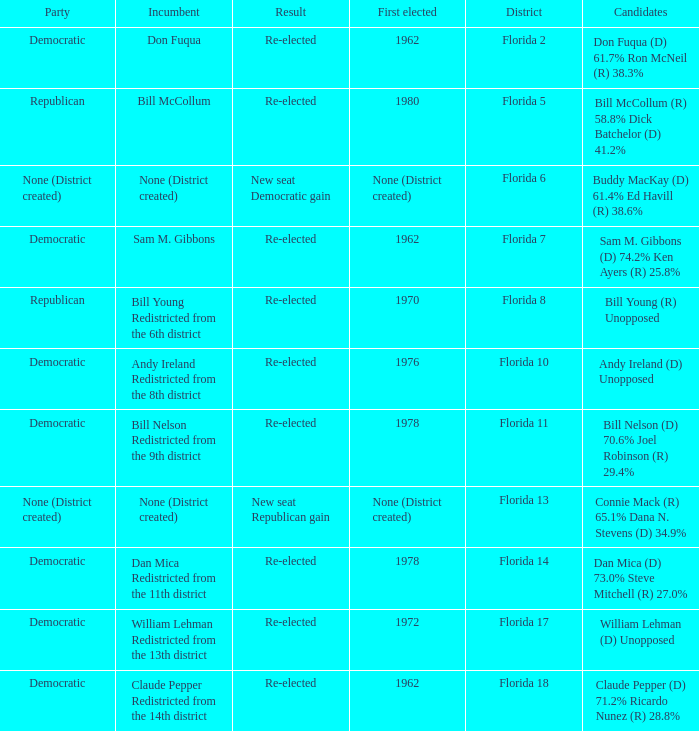What's the first elected with district being florida 7 1962.0. Would you mind parsing the complete table? {'header': ['Party', 'Incumbent', 'Result', 'First elected', 'District', 'Candidates'], 'rows': [['Democratic', 'Don Fuqua', 'Re-elected', '1962', 'Florida 2', 'Don Fuqua (D) 61.7% Ron McNeil (R) 38.3%'], ['Republican', 'Bill McCollum', 'Re-elected', '1980', 'Florida 5', 'Bill McCollum (R) 58.8% Dick Batchelor (D) 41.2%'], ['None (District created)', 'None (District created)', 'New seat Democratic gain', 'None (District created)', 'Florida 6', 'Buddy MacKay (D) 61.4% Ed Havill (R) 38.6%'], ['Democratic', 'Sam M. Gibbons', 'Re-elected', '1962', 'Florida 7', 'Sam M. Gibbons (D) 74.2% Ken Ayers (R) 25.8%'], ['Republican', 'Bill Young Redistricted from the 6th district', 'Re-elected', '1970', 'Florida 8', 'Bill Young (R) Unopposed'], ['Democratic', 'Andy Ireland Redistricted from the 8th district', 'Re-elected', '1976', 'Florida 10', 'Andy Ireland (D) Unopposed'], ['Democratic', 'Bill Nelson Redistricted from the 9th district', 'Re-elected', '1978', 'Florida 11', 'Bill Nelson (D) 70.6% Joel Robinson (R) 29.4%'], ['None (District created)', 'None (District created)', 'New seat Republican gain', 'None (District created)', 'Florida 13', 'Connie Mack (R) 65.1% Dana N. Stevens (D) 34.9%'], ['Democratic', 'Dan Mica Redistricted from the 11th district', 'Re-elected', '1978', 'Florida 14', 'Dan Mica (D) 73.0% Steve Mitchell (R) 27.0%'], ['Democratic', 'William Lehman Redistricted from the 13th district', 'Re-elected', '1972', 'Florida 17', 'William Lehman (D) Unopposed'], ['Democratic', 'Claude Pepper Redistricted from the 14th district', 'Re-elected', '1962', 'Florida 18', 'Claude Pepper (D) 71.2% Ricardo Nunez (R) 28.8%']]} 